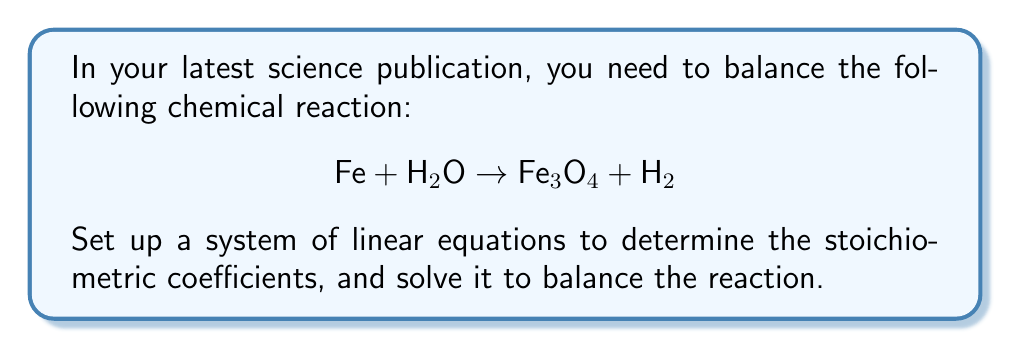Provide a solution to this math problem. Let's approach this step-by-step:

1) First, assign variables to each compound:
   Let $a$ = coefficient of Fe
   Let $b$ = coefficient of H₂O
   Let $c$ = coefficient of Fe₃O₄
   Let $d$ = coefficient of H₂

2) Now, set up equations based on the conservation of each element:

   Fe: $a = 3c$
   H:  $2b = 2d$
   O:  $b = 4c$

3) We have a system of three equations with four unknowns. To solve this, we can express everything in terms of $c$:

   $a = 3c$
   $b = 4c$
   $d = 2c$

4) Now, let's choose the smallest whole number value for $c$ that will make all other coefficients whole numbers:

   $c = 1$

5) Substituting this value:

   $a = 3(1) = 3$
   $b = 4(1) = 4$
   $d = 2(1) = 2$

6) Therefore, the balanced equation is:

   $3\text{Fe} + 4\text{H}_2\text{O} \rightarrow \text{Fe}_3\text{O}_4 + 2\text{H}_2$

7) Verify: 
   Fe: 3 = 3
   H:  8 = 4
   O:  4 = 4

The equation is now balanced.
Answer: $3\text{Fe} + 4\text{H}_2\text{O} \rightarrow \text{Fe}_3\text{O}_4 + 2\text{H}_2$ 